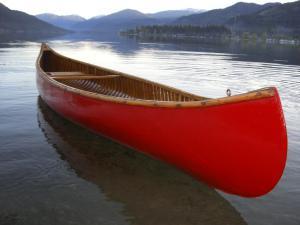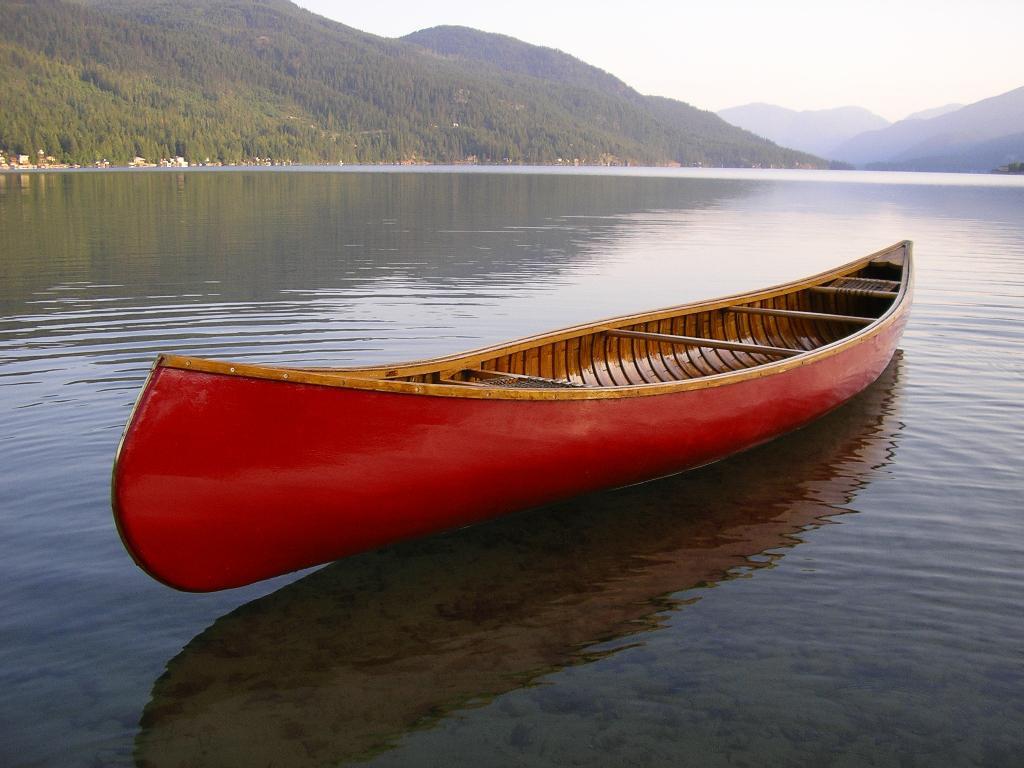The first image is the image on the left, the second image is the image on the right. Considering the images on both sides, is "Both images contain a canoe that is turned toward the right side of the photo." valid? Answer yes or no. No. 